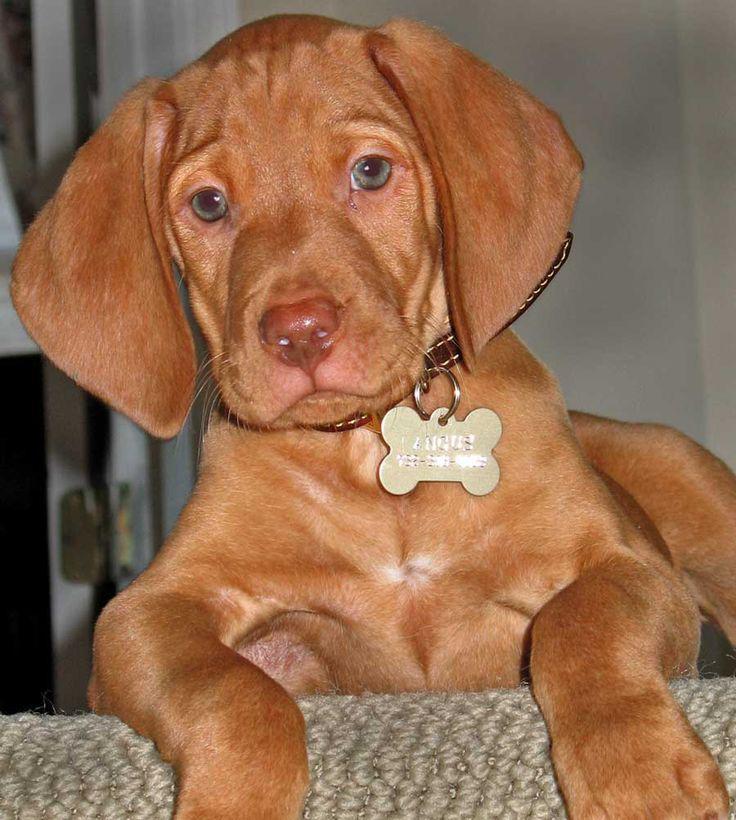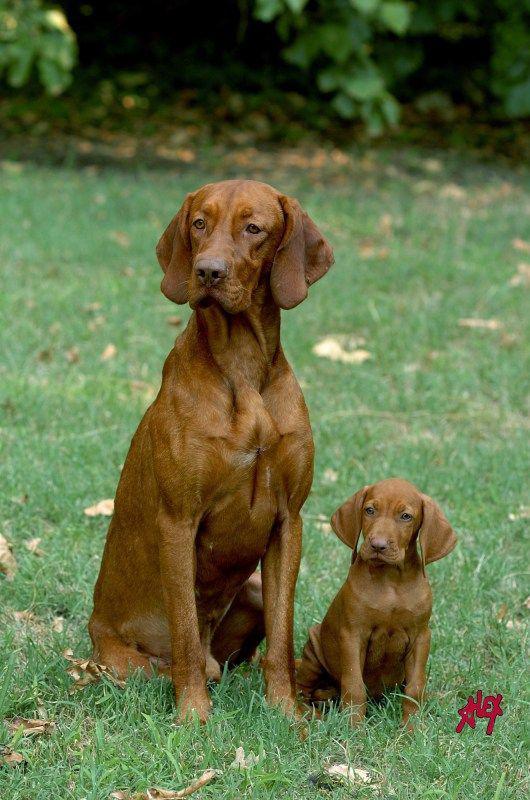The first image is the image on the left, the second image is the image on the right. Analyze the images presented: Is the assertion "All the dogs are sitting." valid? Answer yes or no. No. The first image is the image on the left, the second image is the image on the right. For the images shown, is this caption "Each image shows a single red-orange dog sitting upright, and at least one of the dogs depicted is wearing a collar." true? Answer yes or no. No. 